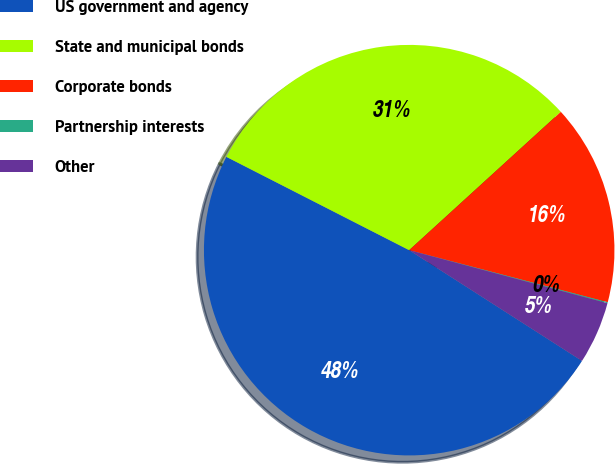Convert chart to OTSL. <chart><loc_0><loc_0><loc_500><loc_500><pie_chart><fcel>US government and agency<fcel>State and municipal bonds<fcel>Corporate bonds<fcel>Partnership interests<fcel>Other<nl><fcel>48.44%<fcel>30.72%<fcel>15.85%<fcel>0.08%<fcel>4.91%<nl></chart> 